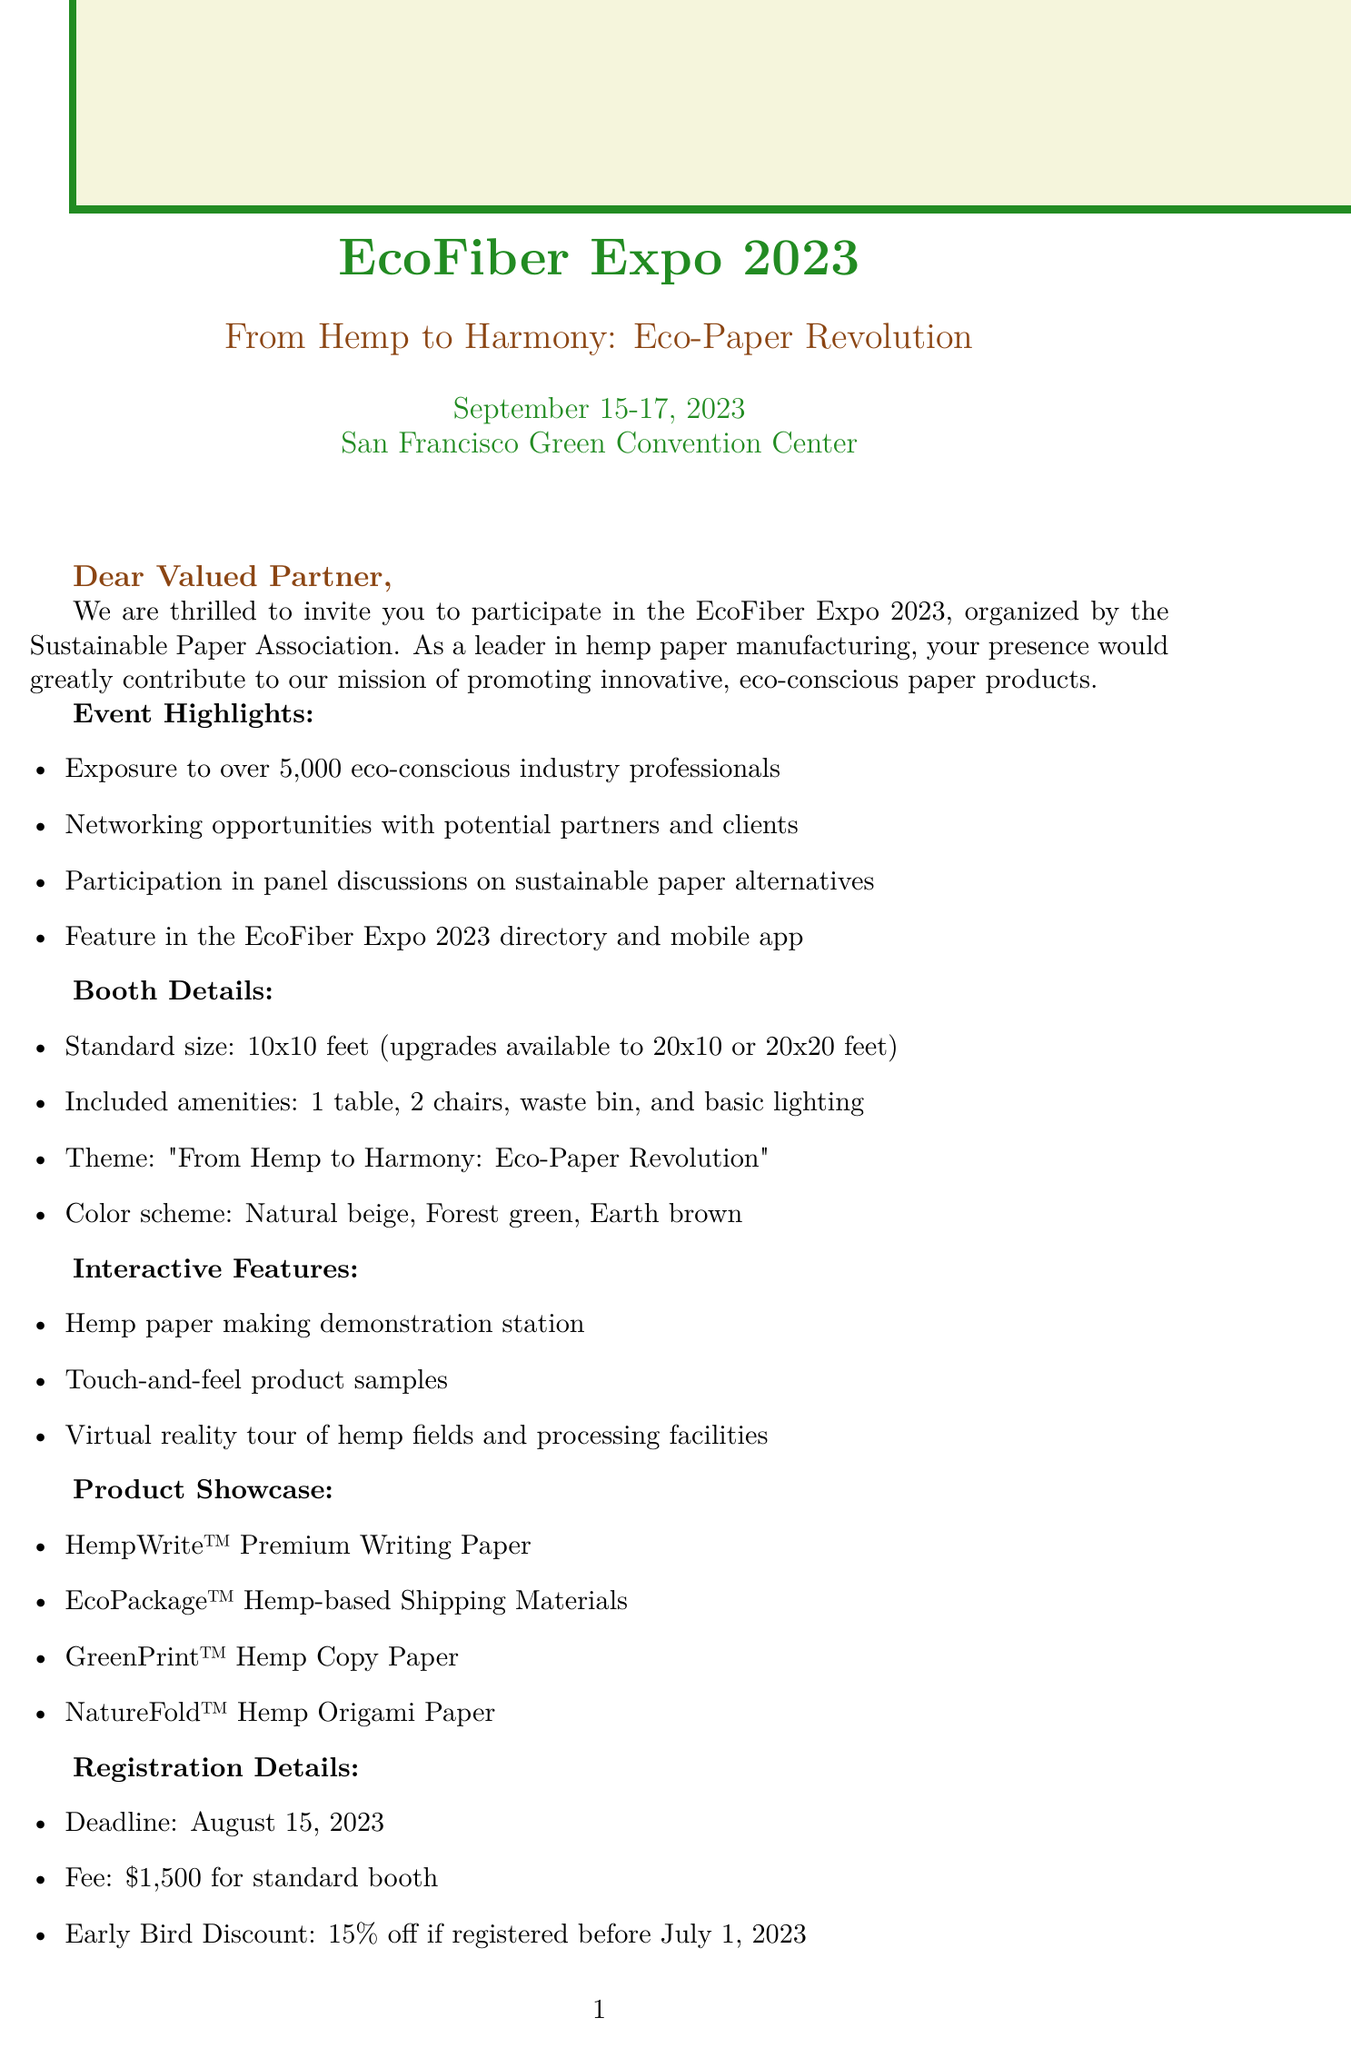What is the event name? The event name is clearly stated in the document as EcoFiber Expo 2023.
Answer: EcoFiber Expo 2023 What are the booth size options? The document lists the standard booth size and available upgrades, which include 10x10 feet, 20x10 feet, and 20x20 feet.
Answer: 10x10 feet, 20x10 feet, 20x20 feet What is the registration deadline? The registration deadline is specified in the document as August 15, 2023.
Answer: August 15, 2023 What is one of the interactive features mentioned? The document describes multiple interactive features at the booth, such as a hemp paper making demonstration station.
Answer: Hemp paper making demonstration station What is the early bird discount percentage? The document states that the early bird discount is 15% off if registered before July 1, 2023.
Answer: 15% Name one product from the product showcase. The product showcase lists several items, one of which is HempWrite™ Premium Writing Paper.
Answer: HempWrite™ Premium Writing Paper Which organization is organizing the event? The document identifies the Sustainable Paper Association as the organizer of the EcoFiber Expo 2023.
Answer: Sustainable Paper Association How many eco-conscious industry professionals are expected? The document mentions that over 5,000 eco-conscious industry professionals are expected to attend the event.
Answer: Over 5,000 